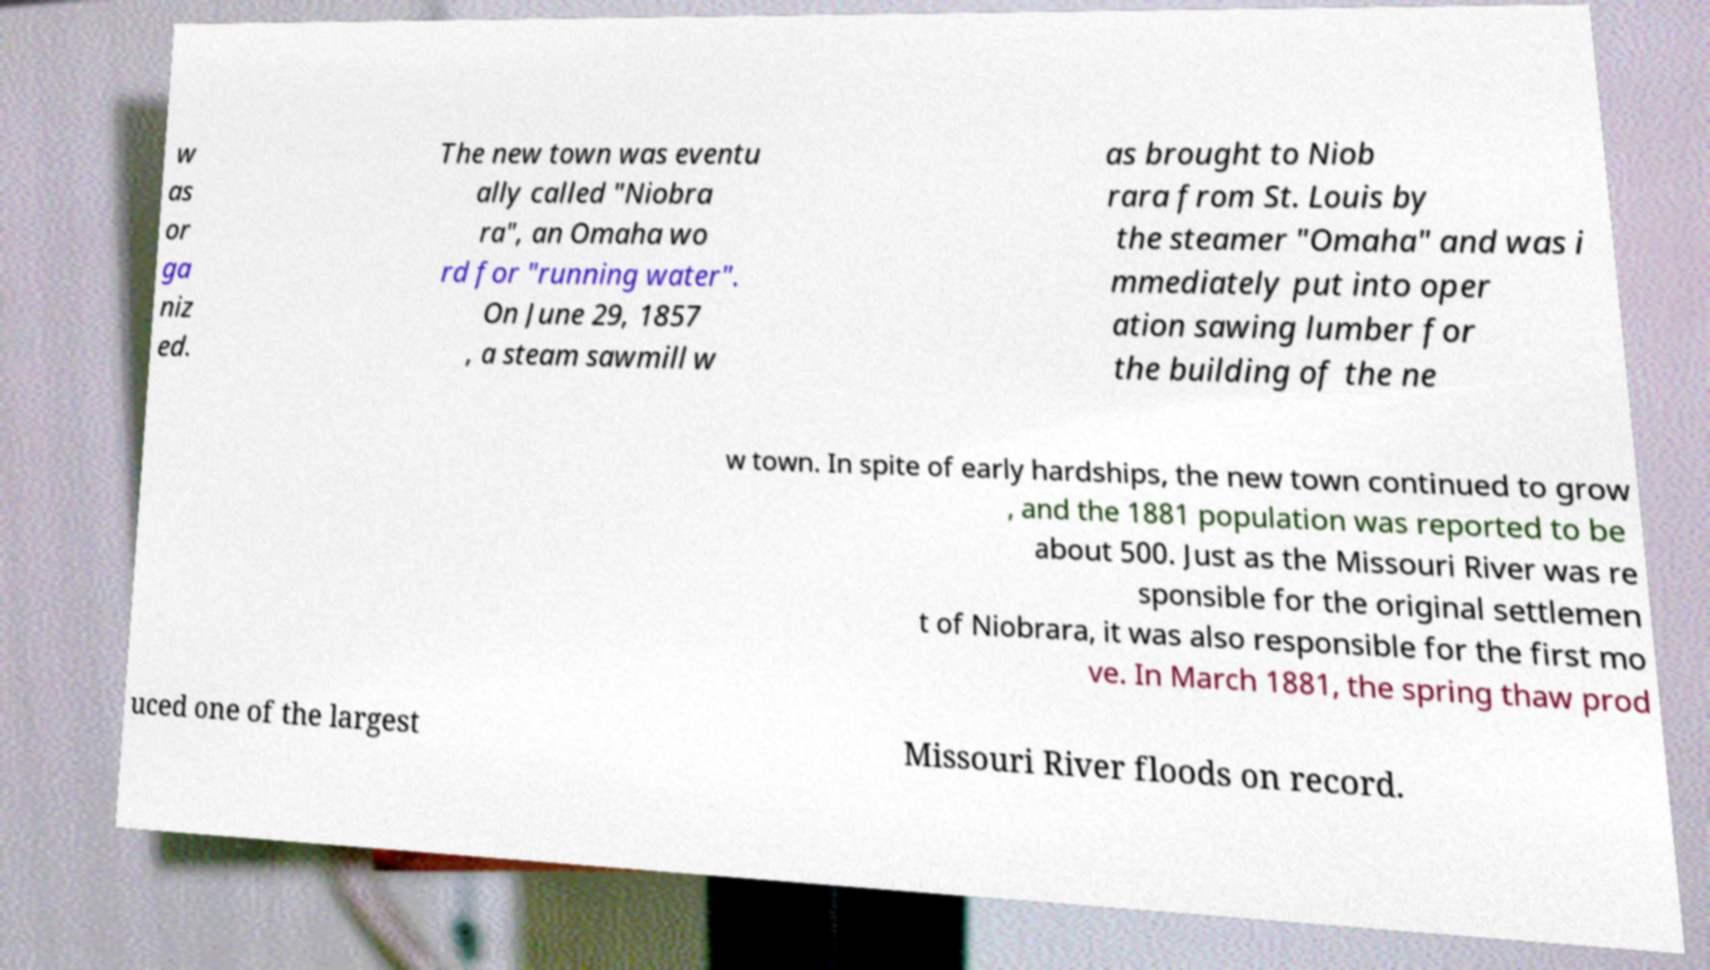What messages or text are displayed in this image? I need them in a readable, typed format. w as or ga niz ed. The new town was eventu ally called "Niobra ra", an Omaha wo rd for "running water". On June 29, 1857 , a steam sawmill w as brought to Niob rara from St. Louis by the steamer "Omaha" and was i mmediately put into oper ation sawing lumber for the building of the ne w town. In spite of early hardships, the new town continued to grow , and the 1881 population was reported to be about 500. Just as the Missouri River was re sponsible for the original settlemen t of Niobrara, it was also responsible for the first mo ve. In March 1881, the spring thaw prod uced one of the largest Missouri River floods on record. 